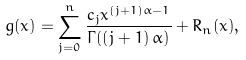Convert formula to latex. <formula><loc_0><loc_0><loc_500><loc_500>g ( x ) = \sum _ { j = 0 } ^ { n } \frac { c _ { j } x ^ { \left ( j + 1 \right ) \alpha - 1 } } { \Gamma ( \left ( j + 1 \right ) \alpha ) } + R _ { n } ( x ) ,</formula> 